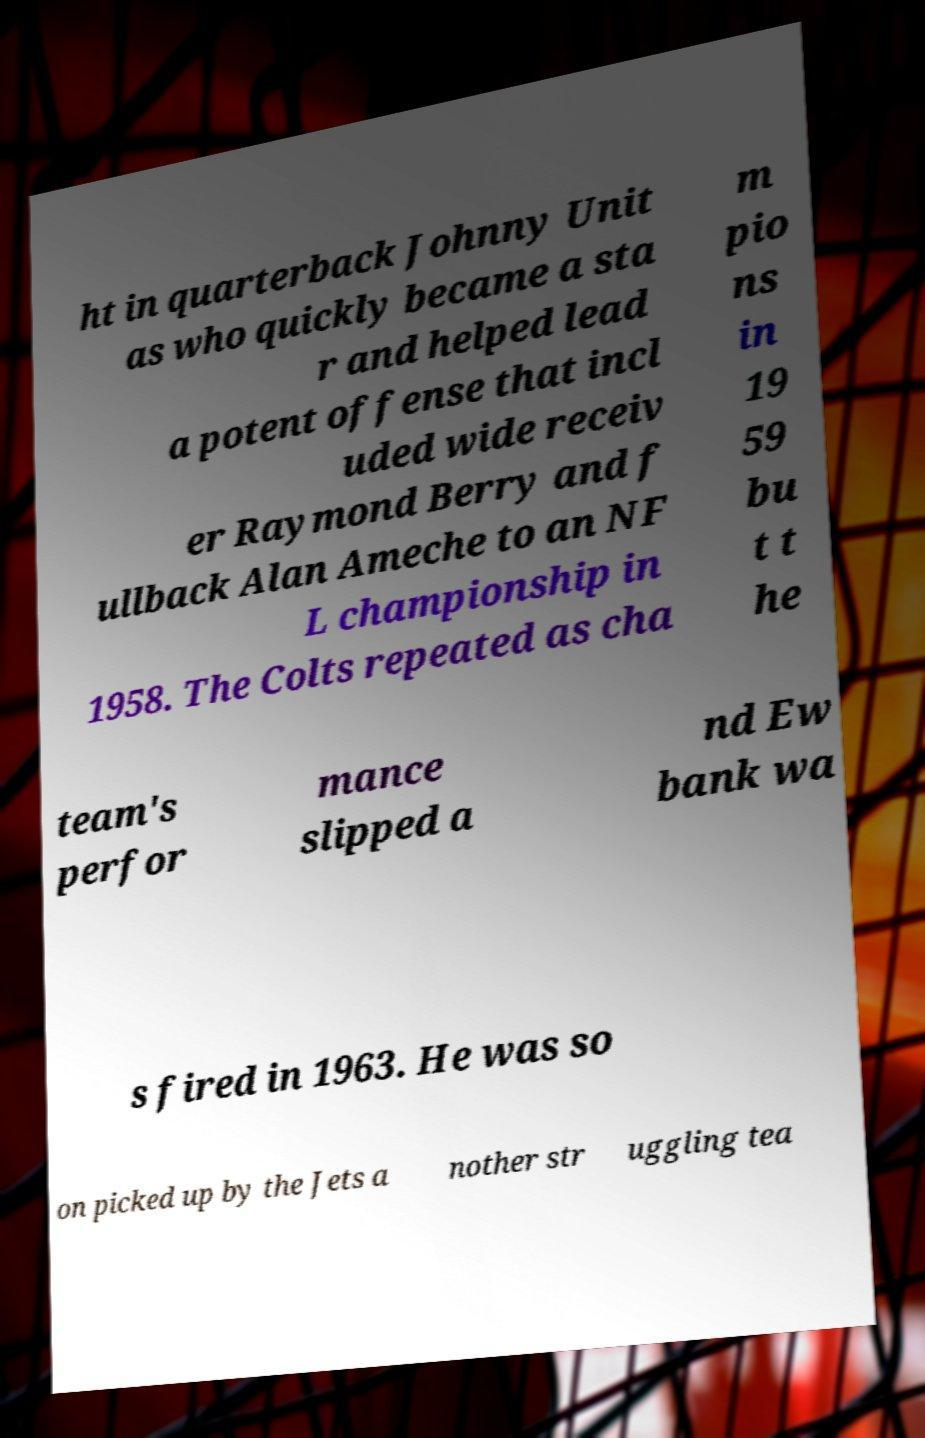Can you accurately transcribe the text from the provided image for me? ht in quarterback Johnny Unit as who quickly became a sta r and helped lead a potent offense that incl uded wide receiv er Raymond Berry and f ullback Alan Ameche to an NF L championship in 1958. The Colts repeated as cha m pio ns in 19 59 bu t t he team's perfor mance slipped a nd Ew bank wa s fired in 1963. He was so on picked up by the Jets a nother str uggling tea 